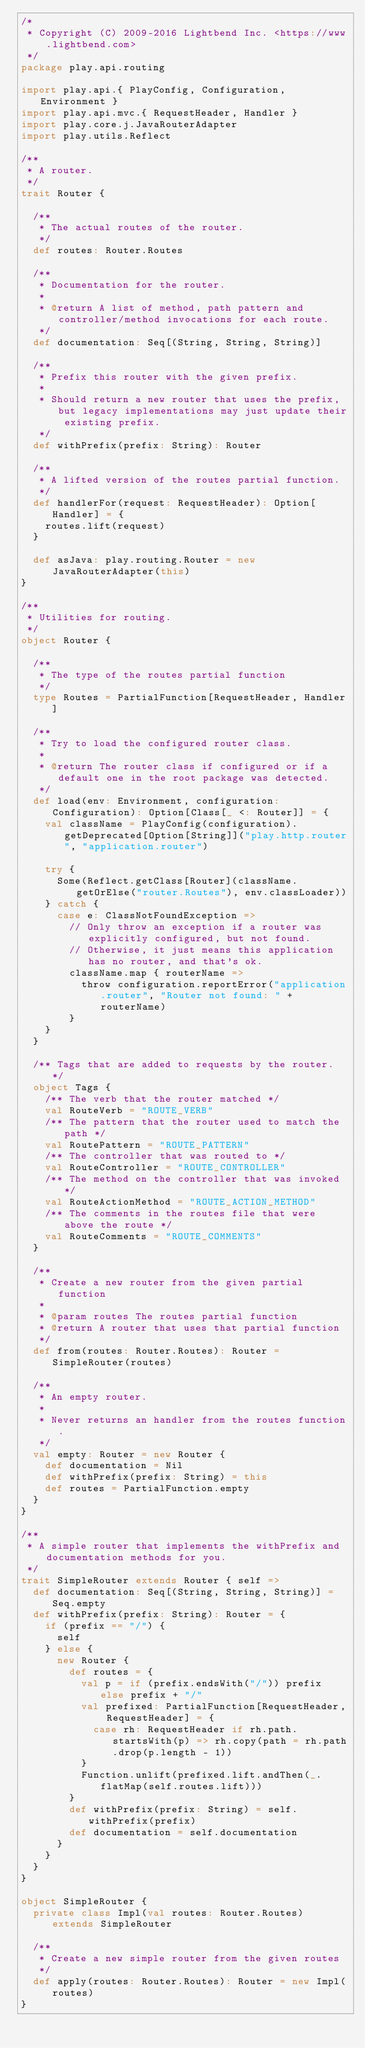Convert code to text. <code><loc_0><loc_0><loc_500><loc_500><_Scala_>/*
 * Copyright (C) 2009-2016 Lightbend Inc. <https://www.lightbend.com>
 */
package play.api.routing

import play.api.{ PlayConfig, Configuration, Environment }
import play.api.mvc.{ RequestHeader, Handler }
import play.core.j.JavaRouterAdapter
import play.utils.Reflect

/**
 * A router.
 */
trait Router {

  /**
   * The actual routes of the router.
   */
  def routes: Router.Routes

  /**
   * Documentation for the router.
   *
   * @return A list of method, path pattern and controller/method invocations for each route.
   */
  def documentation: Seq[(String, String, String)]

  /**
   * Prefix this router with the given prefix.
   *
   * Should return a new router that uses the prefix, but legacy implementations may just update their existing prefix.
   */
  def withPrefix(prefix: String): Router

  /**
   * A lifted version of the routes partial function.
   */
  def handlerFor(request: RequestHeader): Option[Handler] = {
    routes.lift(request)
  }

  def asJava: play.routing.Router = new JavaRouterAdapter(this)
}

/**
 * Utilities for routing.
 */
object Router {

  /**
   * The type of the routes partial function
   */
  type Routes = PartialFunction[RequestHeader, Handler]

  /**
   * Try to load the configured router class.
   *
   * @return The router class if configured or if a default one in the root package was detected.
   */
  def load(env: Environment, configuration: Configuration): Option[Class[_ <: Router]] = {
    val className = PlayConfig(configuration).getDeprecated[Option[String]]("play.http.router", "application.router")

    try {
      Some(Reflect.getClass[Router](className.getOrElse("router.Routes"), env.classLoader))
    } catch {
      case e: ClassNotFoundException =>
        // Only throw an exception if a router was explicitly configured, but not found.
        // Otherwise, it just means this application has no router, and that's ok.
        className.map { routerName =>
          throw configuration.reportError("application.router", "Router not found: " + routerName)
        }
    }
  }

  /** Tags that are added to requests by the router. */
  object Tags {
    /** The verb that the router matched */
    val RouteVerb = "ROUTE_VERB"
    /** The pattern that the router used to match the path */
    val RoutePattern = "ROUTE_PATTERN"
    /** The controller that was routed to */
    val RouteController = "ROUTE_CONTROLLER"
    /** The method on the controller that was invoked */
    val RouteActionMethod = "ROUTE_ACTION_METHOD"
    /** The comments in the routes file that were above the route */
    val RouteComments = "ROUTE_COMMENTS"
  }

  /**
   * Create a new router from the given partial function
   *
   * @param routes The routes partial function
   * @return A router that uses that partial function
   */
  def from(routes: Router.Routes): Router = SimpleRouter(routes)

  /**
   * An empty router.
   *
   * Never returns an handler from the routes function.
   */
  val empty: Router = new Router {
    def documentation = Nil
    def withPrefix(prefix: String) = this
    def routes = PartialFunction.empty
  }
}

/**
 * A simple router that implements the withPrefix and documentation methods for you.
 */
trait SimpleRouter extends Router { self =>
  def documentation: Seq[(String, String, String)] = Seq.empty
  def withPrefix(prefix: String): Router = {
    if (prefix == "/") {
      self
    } else {
      new Router {
        def routes = {
          val p = if (prefix.endsWith("/")) prefix else prefix + "/"
          val prefixed: PartialFunction[RequestHeader, RequestHeader] = {
            case rh: RequestHeader if rh.path.startsWith(p) => rh.copy(path = rh.path.drop(p.length - 1))
          }
          Function.unlift(prefixed.lift.andThen(_.flatMap(self.routes.lift)))
        }
        def withPrefix(prefix: String) = self.withPrefix(prefix)
        def documentation = self.documentation
      }
    }
  }
}

object SimpleRouter {
  private class Impl(val routes: Router.Routes) extends SimpleRouter

  /**
   * Create a new simple router from the given routes
   */
  def apply(routes: Router.Routes): Router = new Impl(routes)
}
</code> 